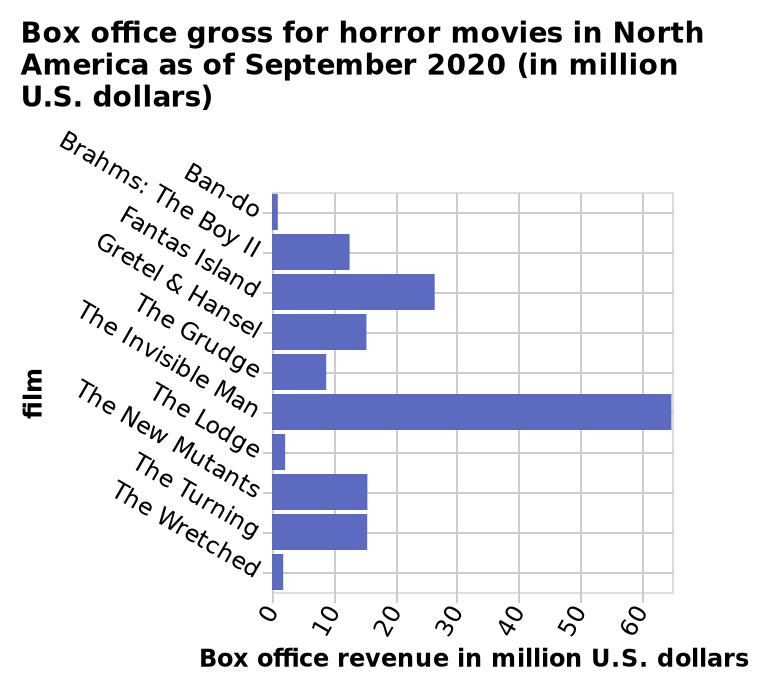<image>
How many horror films in North America grossed over 20 million dollars as of September 2020?  Only 2 horror films in North America grossed over 20 million dollars as of September 2020. please summary the statistics and relations of the chart Only 2 horror films in North America as of September 2020 grossed over 20 million dollar while 4 films grossed less than 10 million dollars. What type of movies are represented in this bar chart?  The bar chart represents the box office gross for horror movies. 